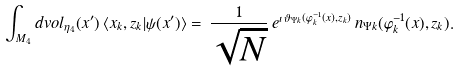Convert formula to latex. <formula><loc_0><loc_0><loc_500><loc_500>\int _ { M _ { 4 } } d v o l _ { \eta _ { 4 } } ( x ^ { \prime } ) \, \langle x _ { k } , z _ { k } | \psi ( x ^ { \prime } ) \rangle = \, \frac { 1 } { \sqrt { N } } \, e ^ { \imath \, \vartheta _ { \Psi k } ( \varphi ^ { - 1 } _ { k } ( x ) , z _ { k } ) } \, n _ { \Psi k } ( \varphi ^ { - 1 } _ { k } ( x ) , z _ { k } ) .</formula> 